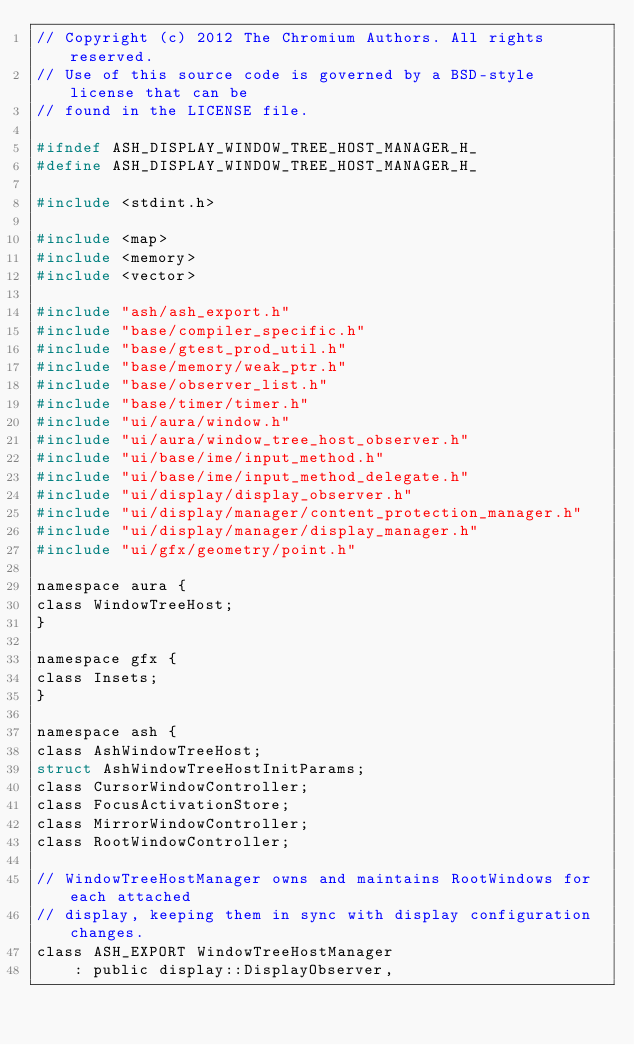Convert code to text. <code><loc_0><loc_0><loc_500><loc_500><_C_>// Copyright (c) 2012 The Chromium Authors. All rights reserved.
// Use of this source code is governed by a BSD-style license that can be
// found in the LICENSE file.

#ifndef ASH_DISPLAY_WINDOW_TREE_HOST_MANAGER_H_
#define ASH_DISPLAY_WINDOW_TREE_HOST_MANAGER_H_

#include <stdint.h>

#include <map>
#include <memory>
#include <vector>

#include "ash/ash_export.h"
#include "base/compiler_specific.h"
#include "base/gtest_prod_util.h"
#include "base/memory/weak_ptr.h"
#include "base/observer_list.h"
#include "base/timer/timer.h"
#include "ui/aura/window.h"
#include "ui/aura/window_tree_host_observer.h"
#include "ui/base/ime/input_method.h"
#include "ui/base/ime/input_method_delegate.h"
#include "ui/display/display_observer.h"
#include "ui/display/manager/content_protection_manager.h"
#include "ui/display/manager/display_manager.h"
#include "ui/gfx/geometry/point.h"

namespace aura {
class WindowTreeHost;
}

namespace gfx {
class Insets;
}

namespace ash {
class AshWindowTreeHost;
struct AshWindowTreeHostInitParams;
class CursorWindowController;
class FocusActivationStore;
class MirrorWindowController;
class RootWindowController;

// WindowTreeHostManager owns and maintains RootWindows for each attached
// display, keeping them in sync with display configuration changes.
class ASH_EXPORT WindowTreeHostManager
    : public display::DisplayObserver,</code> 